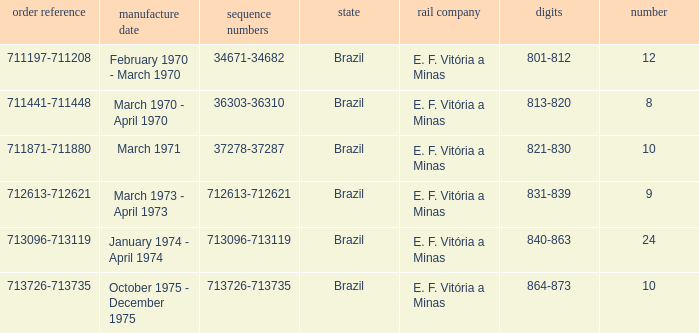The serial numbers 713096-713119 are in which country? Brazil. 